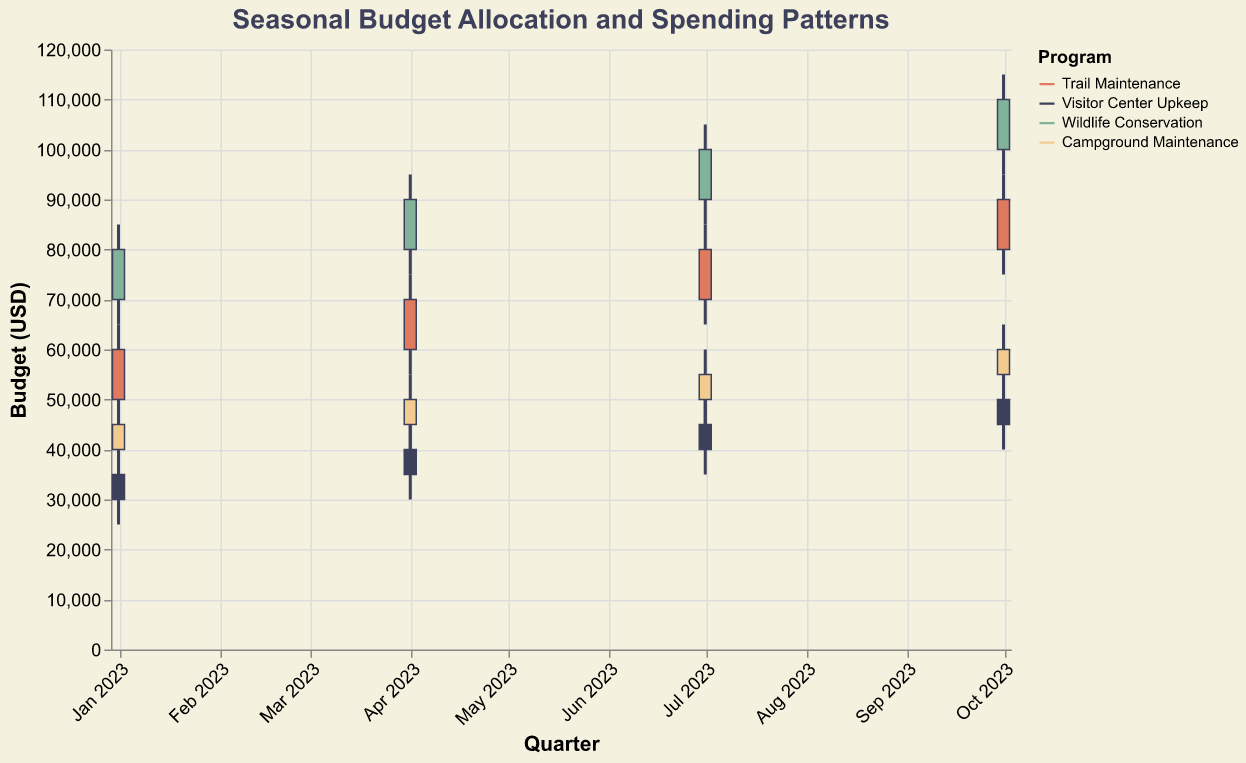What is the title of the figure? The title of the figure is written at the top and it states: "Seasonal Budget Allocation and Spending Patterns".
Answer: Seasonal Budget Allocation and Spending Patterns What is the highest budget allocation for Wildlife Conservation in any quarter? To find this, identify the "High" value for the Wildlife Conservation program. The highest value shown is 115000 in October 2023.
Answer: 115000 How does the budget allocation for Trail Maintenance change from January to October 2023? Review the "Close" values for Trail Maintenance. In January 2023 it is 60000, and in October 2023 it is 90000.
Answer: Increases What is the difference between the highest and lowest budget values for Visitor Center Upkeep in July 2023? In July 2023, the High value is 50000 and the Low value is 35000, so the difference is 50000 - 35000.
Answer: 15000 Which program had the largest increase in budget from April to July 2023? Calculate the difference in the Close values between April and July for each program. Trail Maintenance: 70000 to 80000 (10000), Visitor Center Upkeep: 40000 to 45000 (5000), Wildlife Conservation: 90000 to 100000 (10000), Campground Maintenance: 50000 to 55000 (5000). Trail Maintenance and Wildlife Conservation both increased by 10000.
Answer: Trail Maintenance / Wildlife Conservation What is the average "High" budget value for Campground Maintenance over the four quarters? Add the High values for Campground Maintenance (50000, 55000, 60000, 65000) and divide by 4. (50000 + 55000 + 60000 + 65000) / 4 = 57500.
Answer: 57500 Which program had the smallest gap between Open and Close values in any quarter? Compare the differences (Open - Close) for each program in each quarter. Trail Maintenance shows the smallest gap of 10000, seen in the Close: 60000 and Open: 50000 during January 2023.
Answer: Trail Maintenance In which month did Wildlife Conservation achieve its maximum budget allocation? Find the "High" value for Wildlife Conservation and its corresponding month. The maximum value 115000 is in October 2023.
Answer: October 2023 